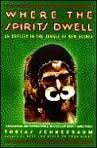Is this book related to Travel? Yes, this book is centrally focused on travel, specifically chronicling the author's explorative journey through the New Guinea Jungle. 